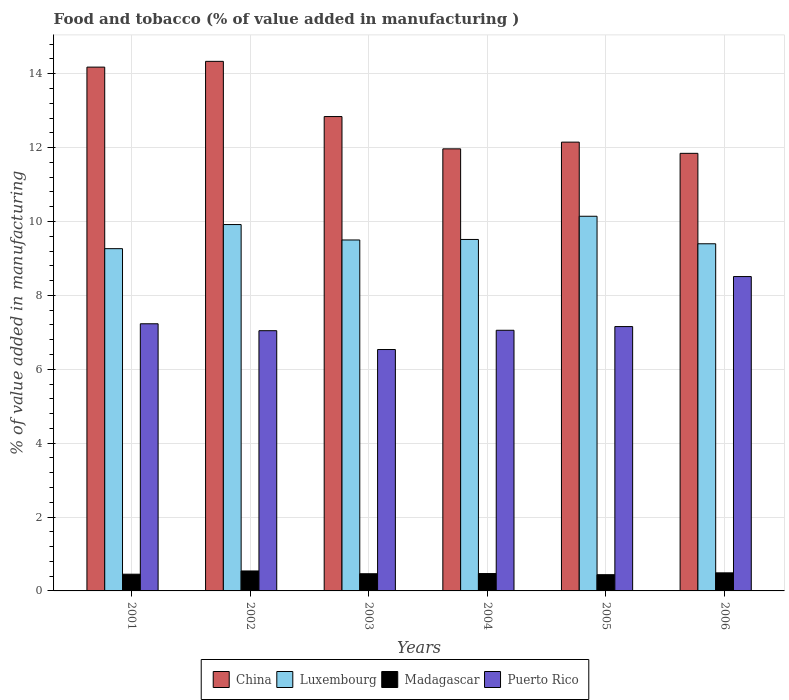How many different coloured bars are there?
Provide a short and direct response. 4. How many groups of bars are there?
Make the answer very short. 6. Are the number of bars per tick equal to the number of legend labels?
Your answer should be compact. Yes. How many bars are there on the 5th tick from the left?
Keep it short and to the point. 4. How many bars are there on the 1st tick from the right?
Offer a terse response. 4. What is the label of the 3rd group of bars from the left?
Your answer should be very brief. 2003. What is the value added in manufacturing food and tobacco in China in 2005?
Provide a succinct answer. 12.15. Across all years, what is the maximum value added in manufacturing food and tobacco in Puerto Rico?
Ensure brevity in your answer.  8.51. Across all years, what is the minimum value added in manufacturing food and tobacco in Madagascar?
Offer a terse response. 0.44. What is the total value added in manufacturing food and tobacco in Luxembourg in the graph?
Offer a very short reply. 57.74. What is the difference between the value added in manufacturing food and tobacco in Luxembourg in 2003 and that in 2006?
Keep it short and to the point. 0.1. What is the difference between the value added in manufacturing food and tobacco in Luxembourg in 2005 and the value added in manufacturing food and tobacco in Madagascar in 2006?
Your answer should be very brief. 9.65. What is the average value added in manufacturing food and tobacco in Madagascar per year?
Your answer should be very brief. 0.48. In the year 2004, what is the difference between the value added in manufacturing food and tobacco in Luxembourg and value added in manufacturing food and tobacco in China?
Your response must be concise. -2.45. In how many years, is the value added in manufacturing food and tobacco in Madagascar greater than 0.8 %?
Ensure brevity in your answer.  0. What is the ratio of the value added in manufacturing food and tobacco in Madagascar in 2003 to that in 2006?
Give a very brief answer. 0.95. Is the value added in manufacturing food and tobacco in Luxembourg in 2001 less than that in 2006?
Offer a terse response. Yes. Is the difference between the value added in manufacturing food and tobacco in Luxembourg in 2001 and 2004 greater than the difference between the value added in manufacturing food and tobacco in China in 2001 and 2004?
Give a very brief answer. No. What is the difference between the highest and the second highest value added in manufacturing food and tobacco in Luxembourg?
Ensure brevity in your answer.  0.22. What is the difference between the highest and the lowest value added in manufacturing food and tobacco in China?
Keep it short and to the point. 2.49. In how many years, is the value added in manufacturing food and tobacco in China greater than the average value added in manufacturing food and tobacco in China taken over all years?
Make the answer very short. 2. Is the sum of the value added in manufacturing food and tobacco in Luxembourg in 2005 and 2006 greater than the maximum value added in manufacturing food and tobacco in Puerto Rico across all years?
Provide a short and direct response. Yes. What does the 3rd bar from the left in 2006 represents?
Offer a very short reply. Madagascar. How many bars are there?
Offer a terse response. 24. How many years are there in the graph?
Your answer should be very brief. 6. What is the difference between two consecutive major ticks on the Y-axis?
Keep it short and to the point. 2. Are the values on the major ticks of Y-axis written in scientific E-notation?
Ensure brevity in your answer.  No. Does the graph contain any zero values?
Your answer should be compact. No. Does the graph contain grids?
Your response must be concise. Yes. Where does the legend appear in the graph?
Give a very brief answer. Bottom center. What is the title of the graph?
Keep it short and to the point. Food and tobacco (% of value added in manufacturing ). What is the label or title of the X-axis?
Give a very brief answer. Years. What is the label or title of the Y-axis?
Your answer should be very brief. % of value added in manufacturing. What is the % of value added in manufacturing of China in 2001?
Offer a terse response. 14.18. What is the % of value added in manufacturing of Luxembourg in 2001?
Give a very brief answer. 9.27. What is the % of value added in manufacturing of Madagascar in 2001?
Provide a succinct answer. 0.45. What is the % of value added in manufacturing of Puerto Rico in 2001?
Your answer should be compact. 7.23. What is the % of value added in manufacturing in China in 2002?
Offer a very short reply. 14.34. What is the % of value added in manufacturing in Luxembourg in 2002?
Your answer should be very brief. 9.92. What is the % of value added in manufacturing in Madagascar in 2002?
Your answer should be compact. 0.54. What is the % of value added in manufacturing of Puerto Rico in 2002?
Your response must be concise. 7.04. What is the % of value added in manufacturing of China in 2003?
Give a very brief answer. 12.84. What is the % of value added in manufacturing in Luxembourg in 2003?
Your answer should be very brief. 9.5. What is the % of value added in manufacturing of Madagascar in 2003?
Offer a very short reply. 0.46. What is the % of value added in manufacturing of Puerto Rico in 2003?
Make the answer very short. 6.54. What is the % of value added in manufacturing in China in 2004?
Make the answer very short. 11.97. What is the % of value added in manufacturing of Luxembourg in 2004?
Provide a short and direct response. 9.51. What is the % of value added in manufacturing in Madagascar in 2004?
Offer a very short reply. 0.47. What is the % of value added in manufacturing of Puerto Rico in 2004?
Provide a short and direct response. 7.06. What is the % of value added in manufacturing in China in 2005?
Your answer should be compact. 12.15. What is the % of value added in manufacturing in Luxembourg in 2005?
Your answer should be compact. 10.14. What is the % of value added in manufacturing in Madagascar in 2005?
Give a very brief answer. 0.44. What is the % of value added in manufacturing of Puerto Rico in 2005?
Make the answer very short. 7.16. What is the % of value added in manufacturing of China in 2006?
Give a very brief answer. 11.85. What is the % of value added in manufacturing of Luxembourg in 2006?
Your answer should be very brief. 9.4. What is the % of value added in manufacturing of Madagascar in 2006?
Your answer should be very brief. 0.49. What is the % of value added in manufacturing in Puerto Rico in 2006?
Give a very brief answer. 8.51. Across all years, what is the maximum % of value added in manufacturing of China?
Your answer should be very brief. 14.34. Across all years, what is the maximum % of value added in manufacturing of Luxembourg?
Offer a very short reply. 10.14. Across all years, what is the maximum % of value added in manufacturing in Madagascar?
Keep it short and to the point. 0.54. Across all years, what is the maximum % of value added in manufacturing of Puerto Rico?
Your answer should be compact. 8.51. Across all years, what is the minimum % of value added in manufacturing of China?
Make the answer very short. 11.85. Across all years, what is the minimum % of value added in manufacturing of Luxembourg?
Make the answer very short. 9.27. Across all years, what is the minimum % of value added in manufacturing in Madagascar?
Ensure brevity in your answer.  0.44. Across all years, what is the minimum % of value added in manufacturing in Puerto Rico?
Give a very brief answer. 6.54. What is the total % of value added in manufacturing in China in the graph?
Offer a terse response. 77.32. What is the total % of value added in manufacturing in Luxembourg in the graph?
Your answer should be very brief. 57.74. What is the total % of value added in manufacturing of Madagascar in the graph?
Keep it short and to the point. 2.86. What is the total % of value added in manufacturing of Puerto Rico in the graph?
Keep it short and to the point. 43.53. What is the difference between the % of value added in manufacturing in China in 2001 and that in 2002?
Your response must be concise. -0.16. What is the difference between the % of value added in manufacturing of Luxembourg in 2001 and that in 2002?
Provide a short and direct response. -0.65. What is the difference between the % of value added in manufacturing in Madagascar in 2001 and that in 2002?
Your response must be concise. -0.09. What is the difference between the % of value added in manufacturing of Puerto Rico in 2001 and that in 2002?
Provide a succinct answer. 0.19. What is the difference between the % of value added in manufacturing in China in 2001 and that in 2003?
Make the answer very short. 1.34. What is the difference between the % of value added in manufacturing of Luxembourg in 2001 and that in 2003?
Offer a very short reply. -0.24. What is the difference between the % of value added in manufacturing of Madagascar in 2001 and that in 2003?
Give a very brief answer. -0.01. What is the difference between the % of value added in manufacturing of Puerto Rico in 2001 and that in 2003?
Ensure brevity in your answer.  0.7. What is the difference between the % of value added in manufacturing in China in 2001 and that in 2004?
Keep it short and to the point. 2.21. What is the difference between the % of value added in manufacturing of Luxembourg in 2001 and that in 2004?
Offer a terse response. -0.25. What is the difference between the % of value added in manufacturing of Madagascar in 2001 and that in 2004?
Offer a very short reply. -0.02. What is the difference between the % of value added in manufacturing in Puerto Rico in 2001 and that in 2004?
Keep it short and to the point. 0.18. What is the difference between the % of value added in manufacturing in China in 2001 and that in 2005?
Offer a very short reply. 2.03. What is the difference between the % of value added in manufacturing in Luxembourg in 2001 and that in 2005?
Make the answer very short. -0.88. What is the difference between the % of value added in manufacturing of Madagascar in 2001 and that in 2005?
Provide a succinct answer. 0.01. What is the difference between the % of value added in manufacturing of Puerto Rico in 2001 and that in 2005?
Provide a succinct answer. 0.08. What is the difference between the % of value added in manufacturing of China in 2001 and that in 2006?
Give a very brief answer. 2.33. What is the difference between the % of value added in manufacturing of Luxembourg in 2001 and that in 2006?
Your answer should be compact. -0.13. What is the difference between the % of value added in manufacturing of Madagascar in 2001 and that in 2006?
Give a very brief answer. -0.04. What is the difference between the % of value added in manufacturing of Puerto Rico in 2001 and that in 2006?
Make the answer very short. -1.28. What is the difference between the % of value added in manufacturing in China in 2002 and that in 2003?
Ensure brevity in your answer.  1.49. What is the difference between the % of value added in manufacturing of Luxembourg in 2002 and that in 2003?
Keep it short and to the point. 0.42. What is the difference between the % of value added in manufacturing of Madagascar in 2002 and that in 2003?
Give a very brief answer. 0.08. What is the difference between the % of value added in manufacturing of Puerto Rico in 2002 and that in 2003?
Provide a short and direct response. 0.51. What is the difference between the % of value added in manufacturing in China in 2002 and that in 2004?
Your answer should be very brief. 2.37. What is the difference between the % of value added in manufacturing in Luxembourg in 2002 and that in 2004?
Your answer should be very brief. 0.4. What is the difference between the % of value added in manufacturing in Madagascar in 2002 and that in 2004?
Your answer should be very brief. 0.07. What is the difference between the % of value added in manufacturing of Puerto Rico in 2002 and that in 2004?
Ensure brevity in your answer.  -0.01. What is the difference between the % of value added in manufacturing in China in 2002 and that in 2005?
Your answer should be very brief. 2.19. What is the difference between the % of value added in manufacturing in Luxembourg in 2002 and that in 2005?
Offer a terse response. -0.22. What is the difference between the % of value added in manufacturing of Madagascar in 2002 and that in 2005?
Your answer should be very brief. 0.1. What is the difference between the % of value added in manufacturing of Puerto Rico in 2002 and that in 2005?
Ensure brevity in your answer.  -0.11. What is the difference between the % of value added in manufacturing of China in 2002 and that in 2006?
Keep it short and to the point. 2.49. What is the difference between the % of value added in manufacturing in Luxembourg in 2002 and that in 2006?
Give a very brief answer. 0.52. What is the difference between the % of value added in manufacturing of Madagascar in 2002 and that in 2006?
Your response must be concise. 0.05. What is the difference between the % of value added in manufacturing in Puerto Rico in 2002 and that in 2006?
Your response must be concise. -1.47. What is the difference between the % of value added in manufacturing in China in 2003 and that in 2004?
Your answer should be very brief. 0.87. What is the difference between the % of value added in manufacturing of Luxembourg in 2003 and that in 2004?
Ensure brevity in your answer.  -0.01. What is the difference between the % of value added in manufacturing in Madagascar in 2003 and that in 2004?
Make the answer very short. -0.01. What is the difference between the % of value added in manufacturing in Puerto Rico in 2003 and that in 2004?
Your answer should be very brief. -0.52. What is the difference between the % of value added in manufacturing in China in 2003 and that in 2005?
Your response must be concise. 0.69. What is the difference between the % of value added in manufacturing of Luxembourg in 2003 and that in 2005?
Make the answer very short. -0.64. What is the difference between the % of value added in manufacturing of Madagascar in 2003 and that in 2005?
Your answer should be very brief. 0.03. What is the difference between the % of value added in manufacturing of Puerto Rico in 2003 and that in 2005?
Provide a succinct answer. -0.62. What is the difference between the % of value added in manufacturing of China in 2003 and that in 2006?
Offer a terse response. 1. What is the difference between the % of value added in manufacturing in Luxembourg in 2003 and that in 2006?
Make the answer very short. 0.1. What is the difference between the % of value added in manufacturing in Madagascar in 2003 and that in 2006?
Your answer should be very brief. -0.02. What is the difference between the % of value added in manufacturing in Puerto Rico in 2003 and that in 2006?
Your response must be concise. -1.98. What is the difference between the % of value added in manufacturing of China in 2004 and that in 2005?
Make the answer very short. -0.18. What is the difference between the % of value added in manufacturing of Luxembourg in 2004 and that in 2005?
Give a very brief answer. -0.63. What is the difference between the % of value added in manufacturing of Madagascar in 2004 and that in 2005?
Your answer should be very brief. 0.03. What is the difference between the % of value added in manufacturing in Puerto Rico in 2004 and that in 2005?
Keep it short and to the point. -0.1. What is the difference between the % of value added in manufacturing in China in 2004 and that in 2006?
Make the answer very short. 0.12. What is the difference between the % of value added in manufacturing of Luxembourg in 2004 and that in 2006?
Offer a terse response. 0.12. What is the difference between the % of value added in manufacturing in Madagascar in 2004 and that in 2006?
Make the answer very short. -0.02. What is the difference between the % of value added in manufacturing of Puerto Rico in 2004 and that in 2006?
Offer a terse response. -1.45. What is the difference between the % of value added in manufacturing of China in 2005 and that in 2006?
Offer a terse response. 0.3. What is the difference between the % of value added in manufacturing in Luxembourg in 2005 and that in 2006?
Give a very brief answer. 0.75. What is the difference between the % of value added in manufacturing in Puerto Rico in 2005 and that in 2006?
Your answer should be compact. -1.35. What is the difference between the % of value added in manufacturing in China in 2001 and the % of value added in manufacturing in Luxembourg in 2002?
Give a very brief answer. 4.26. What is the difference between the % of value added in manufacturing of China in 2001 and the % of value added in manufacturing of Madagascar in 2002?
Your response must be concise. 13.64. What is the difference between the % of value added in manufacturing in China in 2001 and the % of value added in manufacturing in Puerto Rico in 2002?
Your answer should be very brief. 7.14. What is the difference between the % of value added in manufacturing of Luxembourg in 2001 and the % of value added in manufacturing of Madagascar in 2002?
Provide a short and direct response. 8.72. What is the difference between the % of value added in manufacturing in Luxembourg in 2001 and the % of value added in manufacturing in Puerto Rico in 2002?
Your response must be concise. 2.22. What is the difference between the % of value added in manufacturing in Madagascar in 2001 and the % of value added in manufacturing in Puerto Rico in 2002?
Your answer should be very brief. -6.59. What is the difference between the % of value added in manufacturing of China in 2001 and the % of value added in manufacturing of Luxembourg in 2003?
Your response must be concise. 4.68. What is the difference between the % of value added in manufacturing in China in 2001 and the % of value added in manufacturing in Madagascar in 2003?
Ensure brevity in your answer.  13.72. What is the difference between the % of value added in manufacturing of China in 2001 and the % of value added in manufacturing of Puerto Rico in 2003?
Provide a succinct answer. 7.65. What is the difference between the % of value added in manufacturing of Luxembourg in 2001 and the % of value added in manufacturing of Madagascar in 2003?
Ensure brevity in your answer.  8.8. What is the difference between the % of value added in manufacturing of Luxembourg in 2001 and the % of value added in manufacturing of Puerto Rico in 2003?
Your answer should be compact. 2.73. What is the difference between the % of value added in manufacturing in Madagascar in 2001 and the % of value added in manufacturing in Puerto Rico in 2003?
Your answer should be very brief. -6.08. What is the difference between the % of value added in manufacturing of China in 2001 and the % of value added in manufacturing of Luxembourg in 2004?
Offer a terse response. 4.67. What is the difference between the % of value added in manufacturing in China in 2001 and the % of value added in manufacturing in Madagascar in 2004?
Your answer should be compact. 13.71. What is the difference between the % of value added in manufacturing of China in 2001 and the % of value added in manufacturing of Puerto Rico in 2004?
Give a very brief answer. 7.12. What is the difference between the % of value added in manufacturing in Luxembourg in 2001 and the % of value added in manufacturing in Madagascar in 2004?
Provide a short and direct response. 8.79. What is the difference between the % of value added in manufacturing in Luxembourg in 2001 and the % of value added in manufacturing in Puerto Rico in 2004?
Ensure brevity in your answer.  2.21. What is the difference between the % of value added in manufacturing in Madagascar in 2001 and the % of value added in manufacturing in Puerto Rico in 2004?
Provide a succinct answer. -6.6. What is the difference between the % of value added in manufacturing of China in 2001 and the % of value added in manufacturing of Luxembourg in 2005?
Offer a terse response. 4.04. What is the difference between the % of value added in manufacturing in China in 2001 and the % of value added in manufacturing in Madagascar in 2005?
Provide a short and direct response. 13.74. What is the difference between the % of value added in manufacturing in China in 2001 and the % of value added in manufacturing in Puerto Rico in 2005?
Provide a short and direct response. 7.02. What is the difference between the % of value added in manufacturing in Luxembourg in 2001 and the % of value added in manufacturing in Madagascar in 2005?
Your answer should be very brief. 8.83. What is the difference between the % of value added in manufacturing of Luxembourg in 2001 and the % of value added in manufacturing of Puerto Rico in 2005?
Your answer should be very brief. 2.11. What is the difference between the % of value added in manufacturing of Madagascar in 2001 and the % of value added in manufacturing of Puerto Rico in 2005?
Offer a terse response. -6.7. What is the difference between the % of value added in manufacturing in China in 2001 and the % of value added in manufacturing in Luxembourg in 2006?
Offer a very short reply. 4.78. What is the difference between the % of value added in manufacturing in China in 2001 and the % of value added in manufacturing in Madagascar in 2006?
Ensure brevity in your answer.  13.69. What is the difference between the % of value added in manufacturing of China in 2001 and the % of value added in manufacturing of Puerto Rico in 2006?
Your answer should be compact. 5.67. What is the difference between the % of value added in manufacturing in Luxembourg in 2001 and the % of value added in manufacturing in Madagascar in 2006?
Give a very brief answer. 8.78. What is the difference between the % of value added in manufacturing of Luxembourg in 2001 and the % of value added in manufacturing of Puerto Rico in 2006?
Offer a very short reply. 0.76. What is the difference between the % of value added in manufacturing in Madagascar in 2001 and the % of value added in manufacturing in Puerto Rico in 2006?
Provide a succinct answer. -8.06. What is the difference between the % of value added in manufacturing in China in 2002 and the % of value added in manufacturing in Luxembourg in 2003?
Make the answer very short. 4.84. What is the difference between the % of value added in manufacturing in China in 2002 and the % of value added in manufacturing in Madagascar in 2003?
Keep it short and to the point. 13.87. What is the difference between the % of value added in manufacturing in China in 2002 and the % of value added in manufacturing in Puerto Rico in 2003?
Provide a succinct answer. 7.8. What is the difference between the % of value added in manufacturing in Luxembourg in 2002 and the % of value added in manufacturing in Madagascar in 2003?
Your answer should be very brief. 9.45. What is the difference between the % of value added in manufacturing in Luxembourg in 2002 and the % of value added in manufacturing in Puerto Rico in 2003?
Make the answer very short. 3.38. What is the difference between the % of value added in manufacturing in Madagascar in 2002 and the % of value added in manufacturing in Puerto Rico in 2003?
Offer a very short reply. -5.99. What is the difference between the % of value added in manufacturing in China in 2002 and the % of value added in manufacturing in Luxembourg in 2004?
Provide a short and direct response. 4.82. What is the difference between the % of value added in manufacturing of China in 2002 and the % of value added in manufacturing of Madagascar in 2004?
Keep it short and to the point. 13.87. What is the difference between the % of value added in manufacturing of China in 2002 and the % of value added in manufacturing of Puerto Rico in 2004?
Provide a succinct answer. 7.28. What is the difference between the % of value added in manufacturing of Luxembourg in 2002 and the % of value added in manufacturing of Madagascar in 2004?
Your response must be concise. 9.45. What is the difference between the % of value added in manufacturing in Luxembourg in 2002 and the % of value added in manufacturing in Puerto Rico in 2004?
Provide a short and direct response. 2.86. What is the difference between the % of value added in manufacturing of Madagascar in 2002 and the % of value added in manufacturing of Puerto Rico in 2004?
Provide a succinct answer. -6.52. What is the difference between the % of value added in manufacturing in China in 2002 and the % of value added in manufacturing in Luxembourg in 2005?
Your answer should be compact. 4.19. What is the difference between the % of value added in manufacturing of China in 2002 and the % of value added in manufacturing of Madagascar in 2005?
Give a very brief answer. 13.9. What is the difference between the % of value added in manufacturing in China in 2002 and the % of value added in manufacturing in Puerto Rico in 2005?
Provide a succinct answer. 7.18. What is the difference between the % of value added in manufacturing in Luxembourg in 2002 and the % of value added in manufacturing in Madagascar in 2005?
Make the answer very short. 9.48. What is the difference between the % of value added in manufacturing of Luxembourg in 2002 and the % of value added in manufacturing of Puerto Rico in 2005?
Provide a short and direct response. 2.76. What is the difference between the % of value added in manufacturing in Madagascar in 2002 and the % of value added in manufacturing in Puerto Rico in 2005?
Your answer should be very brief. -6.62. What is the difference between the % of value added in manufacturing of China in 2002 and the % of value added in manufacturing of Luxembourg in 2006?
Provide a succinct answer. 4.94. What is the difference between the % of value added in manufacturing in China in 2002 and the % of value added in manufacturing in Madagascar in 2006?
Give a very brief answer. 13.85. What is the difference between the % of value added in manufacturing in China in 2002 and the % of value added in manufacturing in Puerto Rico in 2006?
Give a very brief answer. 5.83. What is the difference between the % of value added in manufacturing in Luxembourg in 2002 and the % of value added in manufacturing in Madagascar in 2006?
Make the answer very short. 9.43. What is the difference between the % of value added in manufacturing of Luxembourg in 2002 and the % of value added in manufacturing of Puerto Rico in 2006?
Offer a terse response. 1.41. What is the difference between the % of value added in manufacturing in Madagascar in 2002 and the % of value added in manufacturing in Puerto Rico in 2006?
Offer a terse response. -7.97. What is the difference between the % of value added in manufacturing of China in 2003 and the % of value added in manufacturing of Luxembourg in 2004?
Make the answer very short. 3.33. What is the difference between the % of value added in manufacturing of China in 2003 and the % of value added in manufacturing of Madagascar in 2004?
Offer a very short reply. 12.37. What is the difference between the % of value added in manufacturing of China in 2003 and the % of value added in manufacturing of Puerto Rico in 2004?
Provide a short and direct response. 5.79. What is the difference between the % of value added in manufacturing in Luxembourg in 2003 and the % of value added in manufacturing in Madagascar in 2004?
Make the answer very short. 9.03. What is the difference between the % of value added in manufacturing in Luxembourg in 2003 and the % of value added in manufacturing in Puerto Rico in 2004?
Provide a succinct answer. 2.44. What is the difference between the % of value added in manufacturing of Madagascar in 2003 and the % of value added in manufacturing of Puerto Rico in 2004?
Your answer should be compact. -6.59. What is the difference between the % of value added in manufacturing in China in 2003 and the % of value added in manufacturing in Luxembourg in 2005?
Provide a succinct answer. 2.7. What is the difference between the % of value added in manufacturing in China in 2003 and the % of value added in manufacturing in Madagascar in 2005?
Give a very brief answer. 12.4. What is the difference between the % of value added in manufacturing of China in 2003 and the % of value added in manufacturing of Puerto Rico in 2005?
Ensure brevity in your answer.  5.69. What is the difference between the % of value added in manufacturing of Luxembourg in 2003 and the % of value added in manufacturing of Madagascar in 2005?
Provide a succinct answer. 9.06. What is the difference between the % of value added in manufacturing of Luxembourg in 2003 and the % of value added in manufacturing of Puerto Rico in 2005?
Offer a terse response. 2.34. What is the difference between the % of value added in manufacturing in Madagascar in 2003 and the % of value added in manufacturing in Puerto Rico in 2005?
Keep it short and to the point. -6.69. What is the difference between the % of value added in manufacturing of China in 2003 and the % of value added in manufacturing of Luxembourg in 2006?
Provide a succinct answer. 3.44. What is the difference between the % of value added in manufacturing in China in 2003 and the % of value added in manufacturing in Madagascar in 2006?
Give a very brief answer. 12.35. What is the difference between the % of value added in manufacturing of China in 2003 and the % of value added in manufacturing of Puerto Rico in 2006?
Provide a succinct answer. 4.33. What is the difference between the % of value added in manufacturing of Luxembourg in 2003 and the % of value added in manufacturing of Madagascar in 2006?
Ensure brevity in your answer.  9.01. What is the difference between the % of value added in manufacturing of Luxembourg in 2003 and the % of value added in manufacturing of Puerto Rico in 2006?
Offer a very short reply. 0.99. What is the difference between the % of value added in manufacturing in Madagascar in 2003 and the % of value added in manufacturing in Puerto Rico in 2006?
Provide a succinct answer. -8.05. What is the difference between the % of value added in manufacturing of China in 2004 and the % of value added in manufacturing of Luxembourg in 2005?
Offer a very short reply. 1.82. What is the difference between the % of value added in manufacturing in China in 2004 and the % of value added in manufacturing in Madagascar in 2005?
Offer a terse response. 11.53. What is the difference between the % of value added in manufacturing in China in 2004 and the % of value added in manufacturing in Puerto Rico in 2005?
Your answer should be compact. 4.81. What is the difference between the % of value added in manufacturing of Luxembourg in 2004 and the % of value added in manufacturing of Madagascar in 2005?
Your answer should be very brief. 9.08. What is the difference between the % of value added in manufacturing in Luxembourg in 2004 and the % of value added in manufacturing in Puerto Rico in 2005?
Offer a terse response. 2.36. What is the difference between the % of value added in manufacturing of Madagascar in 2004 and the % of value added in manufacturing of Puerto Rico in 2005?
Make the answer very short. -6.69. What is the difference between the % of value added in manufacturing of China in 2004 and the % of value added in manufacturing of Luxembourg in 2006?
Keep it short and to the point. 2.57. What is the difference between the % of value added in manufacturing of China in 2004 and the % of value added in manufacturing of Madagascar in 2006?
Make the answer very short. 11.48. What is the difference between the % of value added in manufacturing of China in 2004 and the % of value added in manufacturing of Puerto Rico in 2006?
Offer a very short reply. 3.46. What is the difference between the % of value added in manufacturing of Luxembourg in 2004 and the % of value added in manufacturing of Madagascar in 2006?
Offer a very short reply. 9.03. What is the difference between the % of value added in manufacturing of Madagascar in 2004 and the % of value added in manufacturing of Puerto Rico in 2006?
Offer a very short reply. -8.04. What is the difference between the % of value added in manufacturing in China in 2005 and the % of value added in manufacturing in Luxembourg in 2006?
Give a very brief answer. 2.75. What is the difference between the % of value added in manufacturing of China in 2005 and the % of value added in manufacturing of Madagascar in 2006?
Provide a short and direct response. 11.66. What is the difference between the % of value added in manufacturing of China in 2005 and the % of value added in manufacturing of Puerto Rico in 2006?
Provide a succinct answer. 3.64. What is the difference between the % of value added in manufacturing of Luxembourg in 2005 and the % of value added in manufacturing of Madagascar in 2006?
Provide a short and direct response. 9.65. What is the difference between the % of value added in manufacturing in Luxembourg in 2005 and the % of value added in manufacturing in Puerto Rico in 2006?
Ensure brevity in your answer.  1.63. What is the difference between the % of value added in manufacturing in Madagascar in 2005 and the % of value added in manufacturing in Puerto Rico in 2006?
Your response must be concise. -8.07. What is the average % of value added in manufacturing of China per year?
Provide a short and direct response. 12.89. What is the average % of value added in manufacturing of Luxembourg per year?
Offer a terse response. 9.62. What is the average % of value added in manufacturing in Madagascar per year?
Provide a short and direct response. 0.48. What is the average % of value added in manufacturing of Puerto Rico per year?
Keep it short and to the point. 7.26. In the year 2001, what is the difference between the % of value added in manufacturing of China and % of value added in manufacturing of Luxembourg?
Provide a succinct answer. 4.91. In the year 2001, what is the difference between the % of value added in manufacturing of China and % of value added in manufacturing of Madagascar?
Keep it short and to the point. 13.73. In the year 2001, what is the difference between the % of value added in manufacturing of China and % of value added in manufacturing of Puerto Rico?
Your answer should be very brief. 6.95. In the year 2001, what is the difference between the % of value added in manufacturing of Luxembourg and % of value added in manufacturing of Madagascar?
Keep it short and to the point. 8.81. In the year 2001, what is the difference between the % of value added in manufacturing of Luxembourg and % of value added in manufacturing of Puerto Rico?
Offer a terse response. 2.03. In the year 2001, what is the difference between the % of value added in manufacturing of Madagascar and % of value added in manufacturing of Puerto Rico?
Provide a succinct answer. -6.78. In the year 2002, what is the difference between the % of value added in manufacturing of China and % of value added in manufacturing of Luxembourg?
Your answer should be very brief. 4.42. In the year 2002, what is the difference between the % of value added in manufacturing of China and % of value added in manufacturing of Madagascar?
Make the answer very short. 13.8. In the year 2002, what is the difference between the % of value added in manufacturing in China and % of value added in manufacturing in Puerto Rico?
Offer a very short reply. 7.29. In the year 2002, what is the difference between the % of value added in manufacturing in Luxembourg and % of value added in manufacturing in Madagascar?
Your response must be concise. 9.38. In the year 2002, what is the difference between the % of value added in manufacturing in Luxembourg and % of value added in manufacturing in Puerto Rico?
Your answer should be compact. 2.87. In the year 2002, what is the difference between the % of value added in manufacturing of Madagascar and % of value added in manufacturing of Puerto Rico?
Your answer should be very brief. -6.5. In the year 2003, what is the difference between the % of value added in manufacturing in China and % of value added in manufacturing in Luxembourg?
Ensure brevity in your answer.  3.34. In the year 2003, what is the difference between the % of value added in manufacturing in China and % of value added in manufacturing in Madagascar?
Your answer should be very brief. 12.38. In the year 2003, what is the difference between the % of value added in manufacturing in China and % of value added in manufacturing in Puerto Rico?
Provide a short and direct response. 6.31. In the year 2003, what is the difference between the % of value added in manufacturing in Luxembourg and % of value added in manufacturing in Madagascar?
Make the answer very short. 9.04. In the year 2003, what is the difference between the % of value added in manufacturing in Luxembourg and % of value added in manufacturing in Puerto Rico?
Offer a very short reply. 2.97. In the year 2003, what is the difference between the % of value added in manufacturing of Madagascar and % of value added in manufacturing of Puerto Rico?
Your answer should be very brief. -6.07. In the year 2004, what is the difference between the % of value added in manufacturing in China and % of value added in manufacturing in Luxembourg?
Ensure brevity in your answer.  2.45. In the year 2004, what is the difference between the % of value added in manufacturing of China and % of value added in manufacturing of Madagascar?
Provide a short and direct response. 11.5. In the year 2004, what is the difference between the % of value added in manufacturing of China and % of value added in manufacturing of Puerto Rico?
Your answer should be compact. 4.91. In the year 2004, what is the difference between the % of value added in manufacturing in Luxembourg and % of value added in manufacturing in Madagascar?
Give a very brief answer. 9.04. In the year 2004, what is the difference between the % of value added in manufacturing of Luxembourg and % of value added in manufacturing of Puerto Rico?
Provide a short and direct response. 2.46. In the year 2004, what is the difference between the % of value added in manufacturing of Madagascar and % of value added in manufacturing of Puerto Rico?
Offer a terse response. -6.59. In the year 2005, what is the difference between the % of value added in manufacturing of China and % of value added in manufacturing of Luxembourg?
Offer a terse response. 2.01. In the year 2005, what is the difference between the % of value added in manufacturing in China and % of value added in manufacturing in Madagascar?
Make the answer very short. 11.71. In the year 2005, what is the difference between the % of value added in manufacturing of China and % of value added in manufacturing of Puerto Rico?
Offer a very short reply. 4.99. In the year 2005, what is the difference between the % of value added in manufacturing of Luxembourg and % of value added in manufacturing of Madagascar?
Give a very brief answer. 9.7. In the year 2005, what is the difference between the % of value added in manufacturing in Luxembourg and % of value added in manufacturing in Puerto Rico?
Make the answer very short. 2.99. In the year 2005, what is the difference between the % of value added in manufacturing of Madagascar and % of value added in manufacturing of Puerto Rico?
Keep it short and to the point. -6.72. In the year 2006, what is the difference between the % of value added in manufacturing in China and % of value added in manufacturing in Luxembourg?
Provide a succinct answer. 2.45. In the year 2006, what is the difference between the % of value added in manufacturing in China and % of value added in manufacturing in Madagascar?
Your response must be concise. 11.36. In the year 2006, what is the difference between the % of value added in manufacturing of China and % of value added in manufacturing of Puerto Rico?
Keep it short and to the point. 3.34. In the year 2006, what is the difference between the % of value added in manufacturing in Luxembourg and % of value added in manufacturing in Madagascar?
Ensure brevity in your answer.  8.91. In the year 2006, what is the difference between the % of value added in manufacturing of Luxembourg and % of value added in manufacturing of Puerto Rico?
Provide a short and direct response. 0.89. In the year 2006, what is the difference between the % of value added in manufacturing of Madagascar and % of value added in manufacturing of Puerto Rico?
Your answer should be very brief. -8.02. What is the ratio of the % of value added in manufacturing in China in 2001 to that in 2002?
Your answer should be very brief. 0.99. What is the ratio of the % of value added in manufacturing of Luxembourg in 2001 to that in 2002?
Offer a terse response. 0.93. What is the ratio of the % of value added in manufacturing of Madagascar in 2001 to that in 2002?
Give a very brief answer. 0.84. What is the ratio of the % of value added in manufacturing of Puerto Rico in 2001 to that in 2002?
Offer a terse response. 1.03. What is the ratio of the % of value added in manufacturing of China in 2001 to that in 2003?
Your answer should be compact. 1.1. What is the ratio of the % of value added in manufacturing of Luxembourg in 2001 to that in 2003?
Give a very brief answer. 0.98. What is the ratio of the % of value added in manufacturing of Madagascar in 2001 to that in 2003?
Provide a short and direct response. 0.97. What is the ratio of the % of value added in manufacturing of Puerto Rico in 2001 to that in 2003?
Your response must be concise. 1.11. What is the ratio of the % of value added in manufacturing of China in 2001 to that in 2004?
Your answer should be compact. 1.18. What is the ratio of the % of value added in manufacturing in Luxembourg in 2001 to that in 2004?
Offer a very short reply. 0.97. What is the ratio of the % of value added in manufacturing in Madagascar in 2001 to that in 2004?
Provide a succinct answer. 0.96. What is the ratio of the % of value added in manufacturing of China in 2001 to that in 2005?
Ensure brevity in your answer.  1.17. What is the ratio of the % of value added in manufacturing in Luxembourg in 2001 to that in 2005?
Provide a succinct answer. 0.91. What is the ratio of the % of value added in manufacturing of Madagascar in 2001 to that in 2005?
Offer a very short reply. 1.03. What is the ratio of the % of value added in manufacturing of Puerto Rico in 2001 to that in 2005?
Ensure brevity in your answer.  1.01. What is the ratio of the % of value added in manufacturing of China in 2001 to that in 2006?
Offer a very short reply. 1.2. What is the ratio of the % of value added in manufacturing of Luxembourg in 2001 to that in 2006?
Provide a short and direct response. 0.99. What is the ratio of the % of value added in manufacturing of Madagascar in 2001 to that in 2006?
Ensure brevity in your answer.  0.93. What is the ratio of the % of value added in manufacturing of Puerto Rico in 2001 to that in 2006?
Provide a succinct answer. 0.85. What is the ratio of the % of value added in manufacturing of China in 2002 to that in 2003?
Provide a succinct answer. 1.12. What is the ratio of the % of value added in manufacturing in Luxembourg in 2002 to that in 2003?
Keep it short and to the point. 1.04. What is the ratio of the % of value added in manufacturing of Madagascar in 2002 to that in 2003?
Your answer should be very brief. 1.16. What is the ratio of the % of value added in manufacturing in Puerto Rico in 2002 to that in 2003?
Give a very brief answer. 1.08. What is the ratio of the % of value added in manufacturing in China in 2002 to that in 2004?
Your answer should be compact. 1.2. What is the ratio of the % of value added in manufacturing in Luxembourg in 2002 to that in 2004?
Offer a terse response. 1.04. What is the ratio of the % of value added in manufacturing in Madagascar in 2002 to that in 2004?
Give a very brief answer. 1.15. What is the ratio of the % of value added in manufacturing in Puerto Rico in 2002 to that in 2004?
Give a very brief answer. 1. What is the ratio of the % of value added in manufacturing of China in 2002 to that in 2005?
Ensure brevity in your answer.  1.18. What is the ratio of the % of value added in manufacturing in Luxembourg in 2002 to that in 2005?
Give a very brief answer. 0.98. What is the ratio of the % of value added in manufacturing of Madagascar in 2002 to that in 2005?
Keep it short and to the point. 1.23. What is the ratio of the % of value added in manufacturing in Puerto Rico in 2002 to that in 2005?
Your answer should be very brief. 0.98. What is the ratio of the % of value added in manufacturing in China in 2002 to that in 2006?
Provide a short and direct response. 1.21. What is the ratio of the % of value added in manufacturing in Luxembourg in 2002 to that in 2006?
Make the answer very short. 1.06. What is the ratio of the % of value added in manufacturing in Madagascar in 2002 to that in 2006?
Ensure brevity in your answer.  1.1. What is the ratio of the % of value added in manufacturing in Puerto Rico in 2002 to that in 2006?
Your answer should be very brief. 0.83. What is the ratio of the % of value added in manufacturing of China in 2003 to that in 2004?
Offer a very short reply. 1.07. What is the ratio of the % of value added in manufacturing in Luxembourg in 2003 to that in 2004?
Provide a short and direct response. 1. What is the ratio of the % of value added in manufacturing in Madagascar in 2003 to that in 2004?
Make the answer very short. 0.99. What is the ratio of the % of value added in manufacturing of Puerto Rico in 2003 to that in 2004?
Provide a succinct answer. 0.93. What is the ratio of the % of value added in manufacturing of China in 2003 to that in 2005?
Keep it short and to the point. 1.06. What is the ratio of the % of value added in manufacturing in Luxembourg in 2003 to that in 2005?
Your answer should be compact. 0.94. What is the ratio of the % of value added in manufacturing of Madagascar in 2003 to that in 2005?
Give a very brief answer. 1.06. What is the ratio of the % of value added in manufacturing of Puerto Rico in 2003 to that in 2005?
Ensure brevity in your answer.  0.91. What is the ratio of the % of value added in manufacturing in China in 2003 to that in 2006?
Give a very brief answer. 1.08. What is the ratio of the % of value added in manufacturing in Luxembourg in 2003 to that in 2006?
Provide a short and direct response. 1.01. What is the ratio of the % of value added in manufacturing of Madagascar in 2003 to that in 2006?
Provide a short and direct response. 0.95. What is the ratio of the % of value added in manufacturing in Puerto Rico in 2003 to that in 2006?
Provide a succinct answer. 0.77. What is the ratio of the % of value added in manufacturing of China in 2004 to that in 2005?
Provide a short and direct response. 0.98. What is the ratio of the % of value added in manufacturing in Luxembourg in 2004 to that in 2005?
Your answer should be very brief. 0.94. What is the ratio of the % of value added in manufacturing in Madagascar in 2004 to that in 2005?
Offer a very short reply. 1.07. What is the ratio of the % of value added in manufacturing of Puerto Rico in 2004 to that in 2005?
Your response must be concise. 0.99. What is the ratio of the % of value added in manufacturing of China in 2004 to that in 2006?
Provide a succinct answer. 1.01. What is the ratio of the % of value added in manufacturing in Luxembourg in 2004 to that in 2006?
Provide a succinct answer. 1.01. What is the ratio of the % of value added in manufacturing of Madagascar in 2004 to that in 2006?
Your answer should be compact. 0.96. What is the ratio of the % of value added in manufacturing of Puerto Rico in 2004 to that in 2006?
Keep it short and to the point. 0.83. What is the ratio of the % of value added in manufacturing of China in 2005 to that in 2006?
Provide a short and direct response. 1.03. What is the ratio of the % of value added in manufacturing of Luxembourg in 2005 to that in 2006?
Provide a succinct answer. 1.08. What is the ratio of the % of value added in manufacturing of Madagascar in 2005 to that in 2006?
Give a very brief answer. 0.9. What is the ratio of the % of value added in manufacturing of Puerto Rico in 2005 to that in 2006?
Provide a short and direct response. 0.84. What is the difference between the highest and the second highest % of value added in manufacturing of China?
Ensure brevity in your answer.  0.16. What is the difference between the highest and the second highest % of value added in manufacturing in Luxembourg?
Make the answer very short. 0.22. What is the difference between the highest and the second highest % of value added in manufacturing of Madagascar?
Keep it short and to the point. 0.05. What is the difference between the highest and the second highest % of value added in manufacturing in Puerto Rico?
Provide a short and direct response. 1.28. What is the difference between the highest and the lowest % of value added in manufacturing of China?
Keep it short and to the point. 2.49. What is the difference between the highest and the lowest % of value added in manufacturing in Luxembourg?
Offer a very short reply. 0.88. What is the difference between the highest and the lowest % of value added in manufacturing of Madagascar?
Provide a succinct answer. 0.1. What is the difference between the highest and the lowest % of value added in manufacturing in Puerto Rico?
Your answer should be compact. 1.98. 